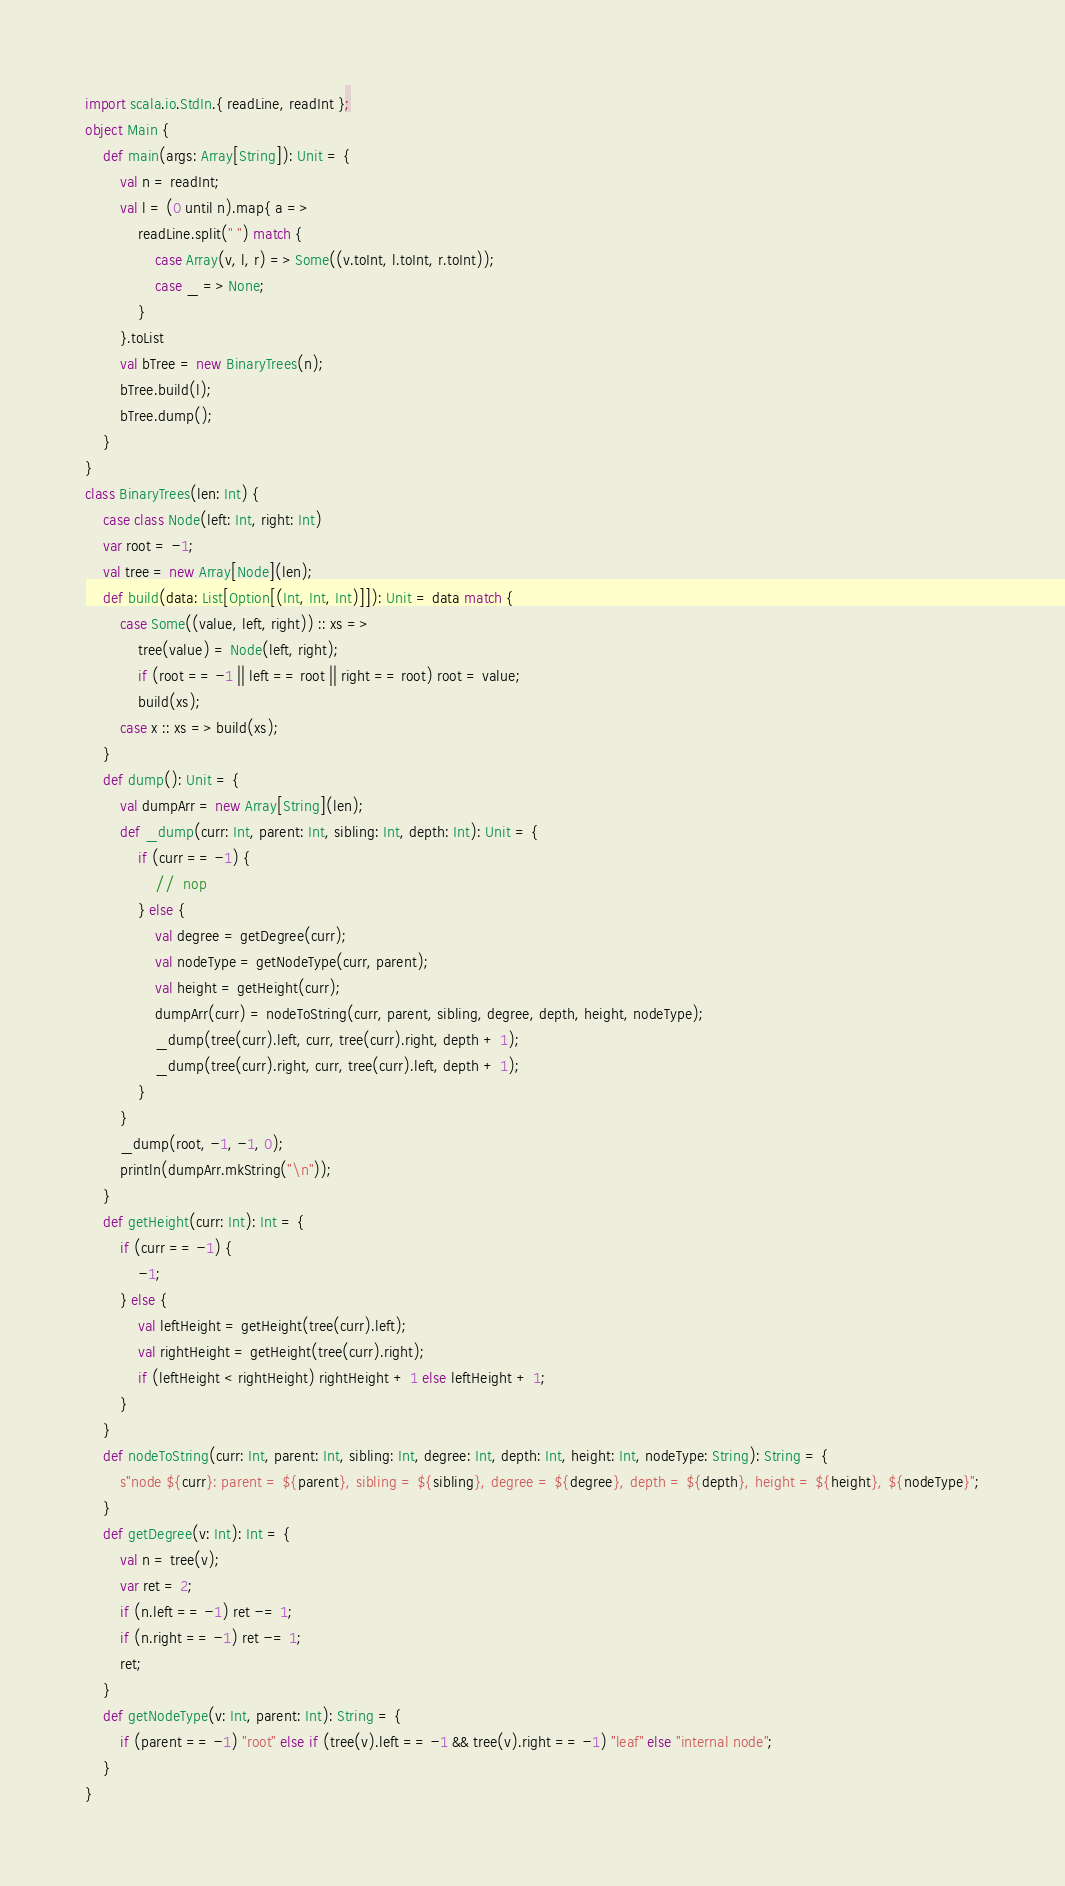<code> <loc_0><loc_0><loc_500><loc_500><_Scala_>import scala.io.StdIn.{ readLine, readInt };
object Main {
    def main(args: Array[String]): Unit = {
        val n = readInt;
        val l = (0 until n).map{ a => 
            readLine.split(" ") match {
                case Array(v, l, r) => Some((v.toInt, l.toInt, r.toInt));
                case _ => None;
            }
        }.toList
        val bTree = new BinaryTrees(n);
        bTree.build(l);
        bTree.dump();
    }
}
class BinaryTrees(len: Int) {
    case class Node(left: Int, right: Int)
    var root = -1;
    val tree = new Array[Node](len);
    def build(data: List[Option[(Int, Int, Int)]]): Unit = data match {
        case Some((value, left, right)) :: xs =>
            tree(value) = Node(left, right);
            if (root == -1 || left == root || right == root) root = value;
            build(xs);
        case x :: xs => build(xs);
    }
    def dump(): Unit = {
        val dumpArr = new Array[String](len);
        def _dump(curr: Int, parent: Int, sibling: Int, depth: Int): Unit = {
            if (curr == -1) {
                //  nop
            } else {
                val degree = getDegree(curr);
                val nodeType = getNodeType(curr, parent);
                val height = getHeight(curr);
                dumpArr(curr) = nodeToString(curr, parent, sibling, degree, depth, height, nodeType);
                _dump(tree(curr).left, curr, tree(curr).right, depth + 1);
                _dump(tree(curr).right, curr, tree(curr).left, depth + 1);
            }
        }
        _dump(root, -1, -1, 0);
        println(dumpArr.mkString("\n"));
    }
    def getHeight(curr: Int): Int = {
        if (curr == -1) {
            -1;
        } else {
            val leftHeight = getHeight(tree(curr).left);
            val rightHeight = getHeight(tree(curr).right);
            if (leftHeight < rightHeight) rightHeight + 1 else leftHeight + 1;
        }
    }
    def nodeToString(curr: Int, parent: Int, sibling: Int, degree: Int, depth: Int, height: Int, nodeType: String): String = {
        s"node ${curr}: parent = ${parent}, sibling = ${sibling}, degree = ${degree}, depth = ${depth}, height = ${height}, ${nodeType}";
    }
    def getDegree(v: Int): Int = {
        val n = tree(v);
        var ret = 2;
        if (n.left == -1) ret -= 1;
        if (n.right == -1) ret -= 1;
        ret;
    }
    def getNodeType(v: Int, parent: Int): String = {
        if (parent == -1) "root" else if (tree(v).left == -1 && tree(v).right == -1) "leaf" else "internal node";
    }
}
</code> 